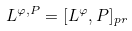Convert formula to latex. <formula><loc_0><loc_0><loc_500><loc_500>L ^ { \varphi , P } = [ L ^ { \varphi } , P ] _ { p r }</formula> 